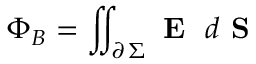Convert formula to latex. <formula><loc_0><loc_0><loc_500><loc_500>\Phi _ { B } = \iint _ { \partial \, \Sigma } E \, d S</formula> 